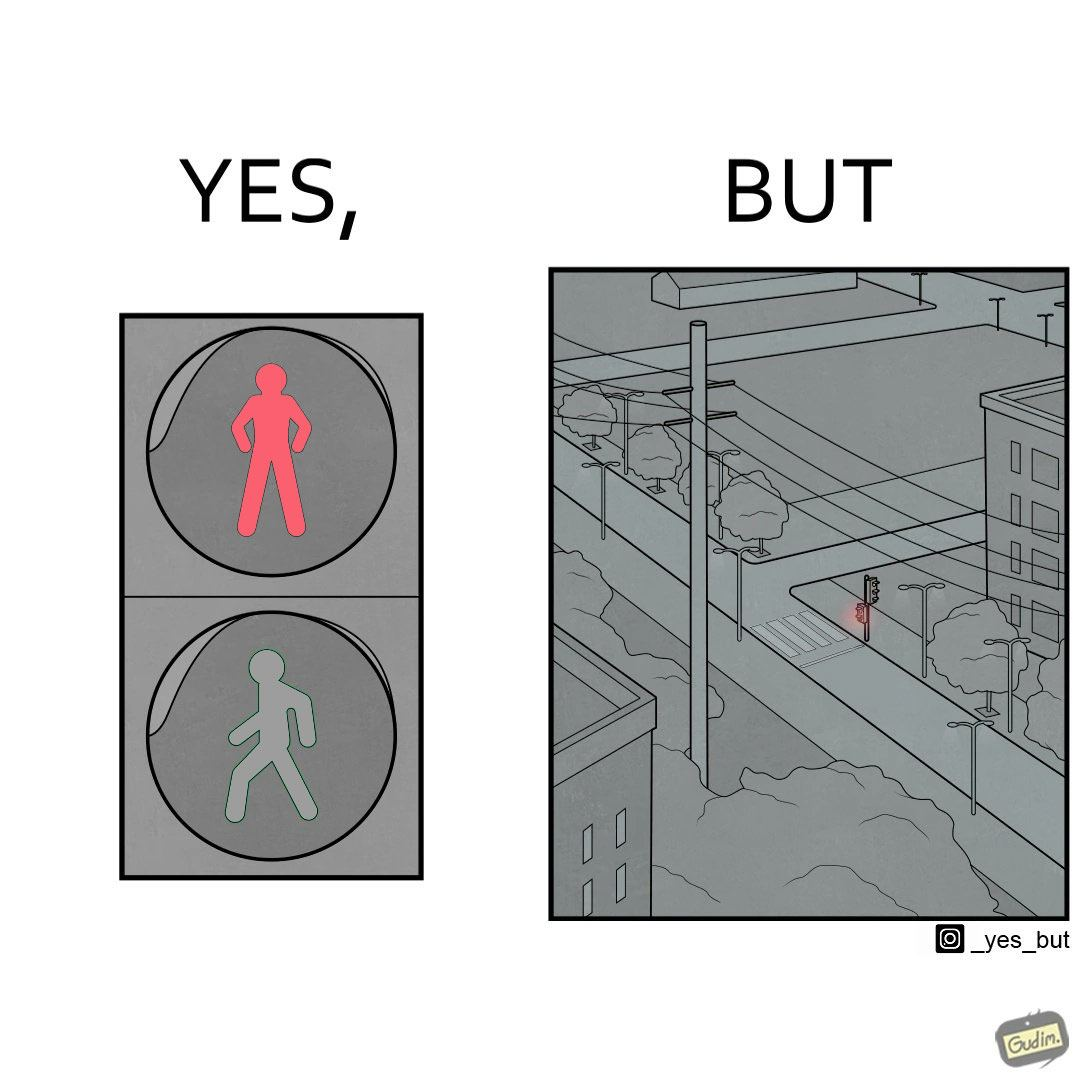Is this a satirical image? Yes, this image is satirical. 